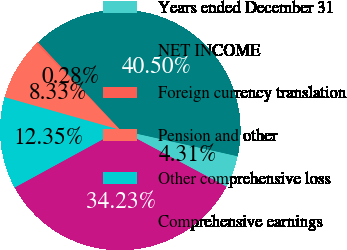Convert chart. <chart><loc_0><loc_0><loc_500><loc_500><pie_chart><fcel>Years ended December 31<fcel>NET INCOME<fcel>Foreign currency translation<fcel>Pension and other<fcel>Other comprehensive loss<fcel>Comprehensive earnings<nl><fcel>4.31%<fcel>40.5%<fcel>0.28%<fcel>8.33%<fcel>12.35%<fcel>34.23%<nl></chart> 